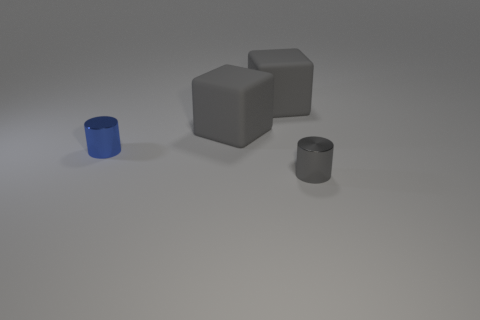Add 3 tiny blue shiny cylinders. How many objects exist? 7 Add 3 tiny objects. How many tiny objects exist? 5 Subtract 1 blue cylinders. How many objects are left? 3 Subtract all small red blocks. Subtract all blue cylinders. How many objects are left? 3 Add 2 tiny blue metal cylinders. How many tiny blue metal cylinders are left? 3 